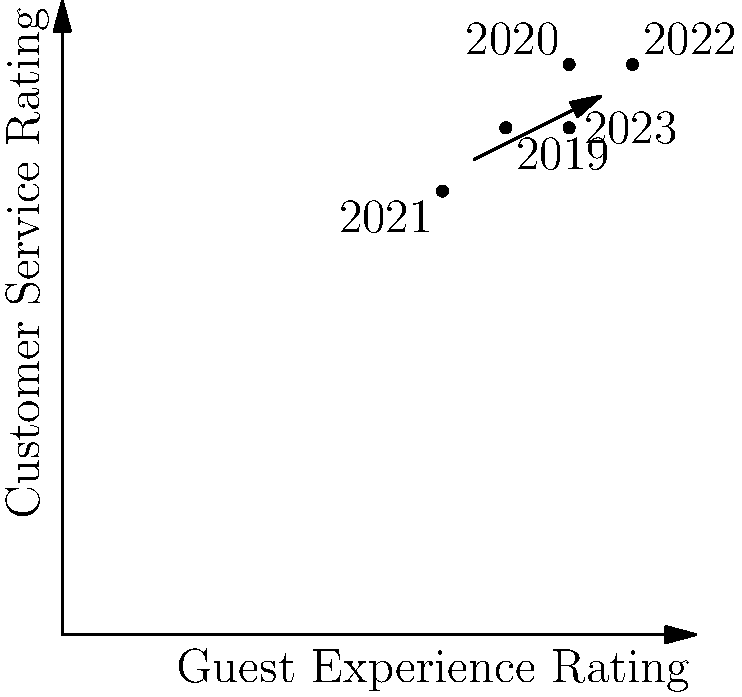The graph shows guest satisfaction ratings for your hostel over the past five years, plotting Guest Experience Rating against Customer Service Rating. What general trend can be observed, and which year showed the most significant improvement from the previous year? To answer this question, let's analyze the data points step-by-step:

1. Plot interpretation:
   - X-axis represents Guest Experience Rating (0-10)
   - Y-axis represents Customer Service Rating (0-10)
   - Each point represents a year from 2019 to 2023

2. Data points:
   - 2019: (7, 8)
   - 2020: (8, 9)
   - 2021: (6, 7)
   - 2022: (9, 9)
   - 2023: (8, 8)

3. General trend:
   - Despite some fluctuations, there's an overall upward trend from 2019 to 2023
   - This is indicated by the arrow on the graph moving from bottom-left to top-right

4. Year-to-year changes:
   - 2019 to 2020: Improved in both ratings
   - 2020 to 2021: Decreased in both ratings
   - 2021 to 2022: Significant improvement in both ratings
   - 2022 to 2023: Slight decrease in both ratings

5. Most significant improvement:
   - The largest positive change occurred from 2021 to 2022
   - Guest Experience Rating increased from 6 to 9 (+3 points)
   - Customer Service Rating increased from 7 to 9 (+2 points)

Therefore, the general trend is upward, and 2022 showed the most significant improvement from the previous year.
Answer: Upward trend; 2022 